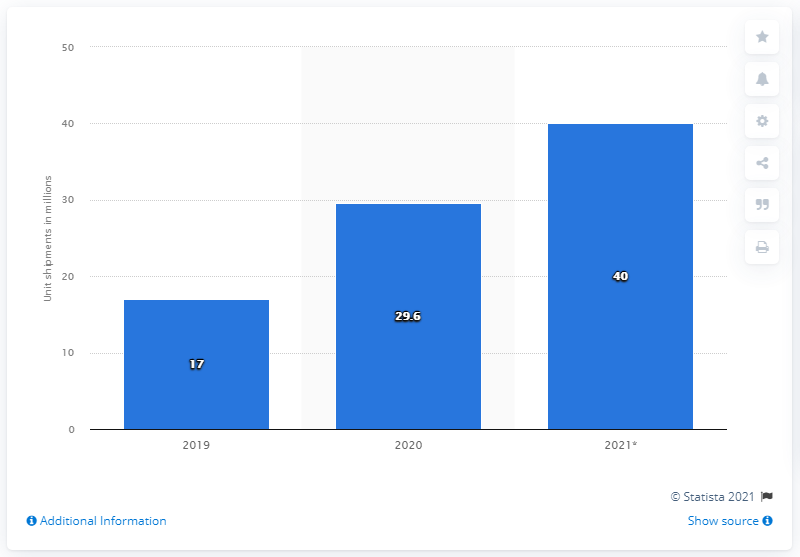List a handful of essential elements in this visual. In 2021, it is projected that globally, 40 Chromebooks will be shipped. 